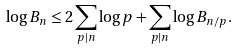<formula> <loc_0><loc_0><loc_500><loc_500>\log B _ { n } \leq 2 \sum _ { p | n } \log p + \sum _ { p | n } \log B _ { { n } / { p } } .</formula> 